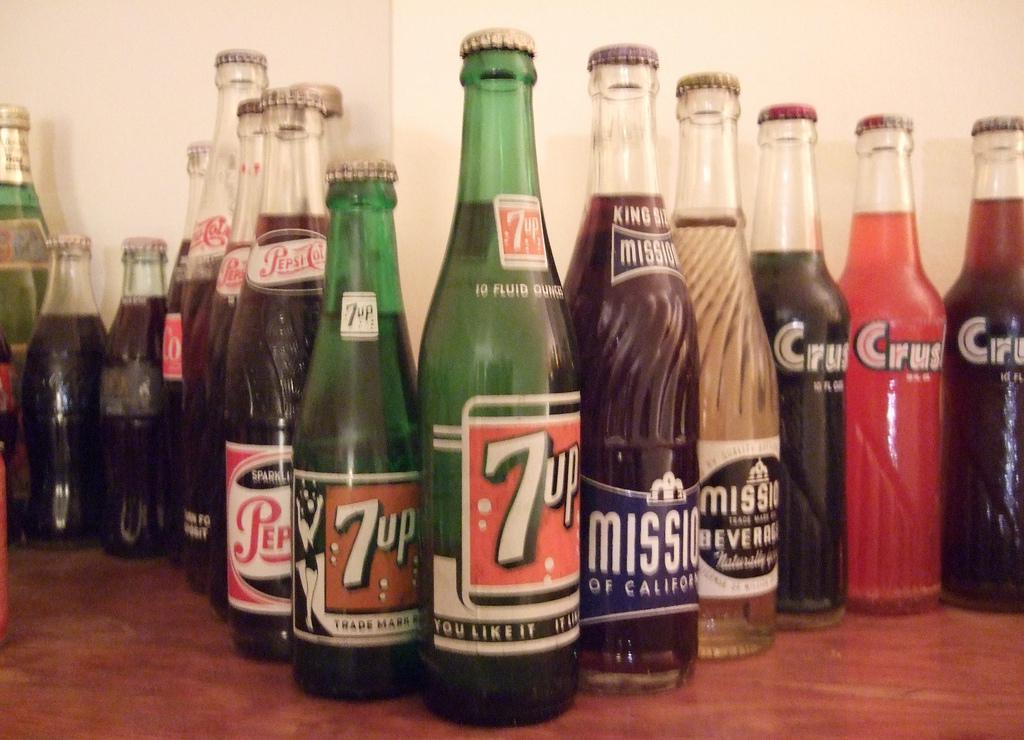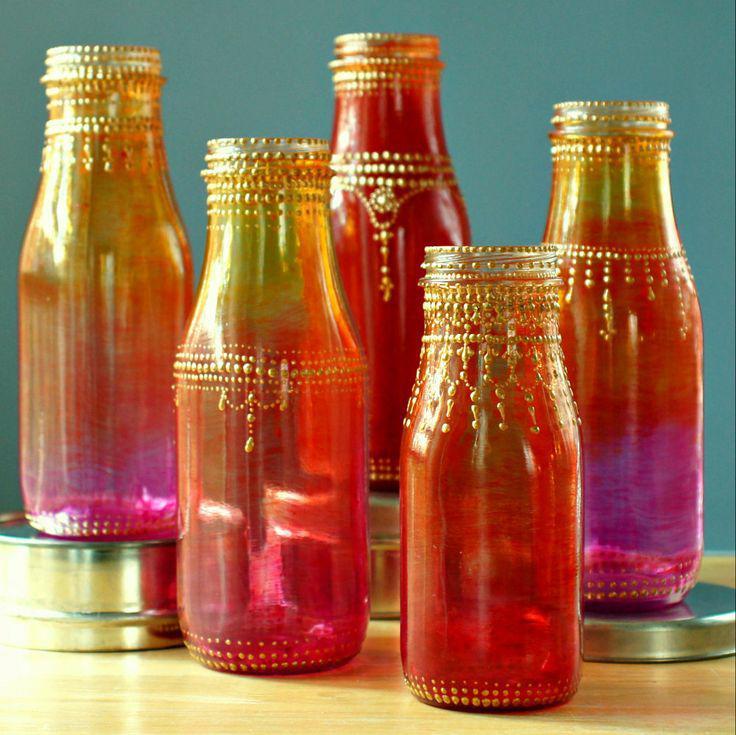The first image is the image on the left, the second image is the image on the right. Assess this claim about the two images: "The bottles in one of the images have been painted.". Correct or not? Answer yes or no. Yes. The first image is the image on the left, the second image is the image on the right. Evaluate the accuracy of this statement regarding the images: "One image shows a group of overlapping old-fashioned glass soda bottles with a variety of labels, shapes and sizes.". Is it true? Answer yes or no. Yes. 